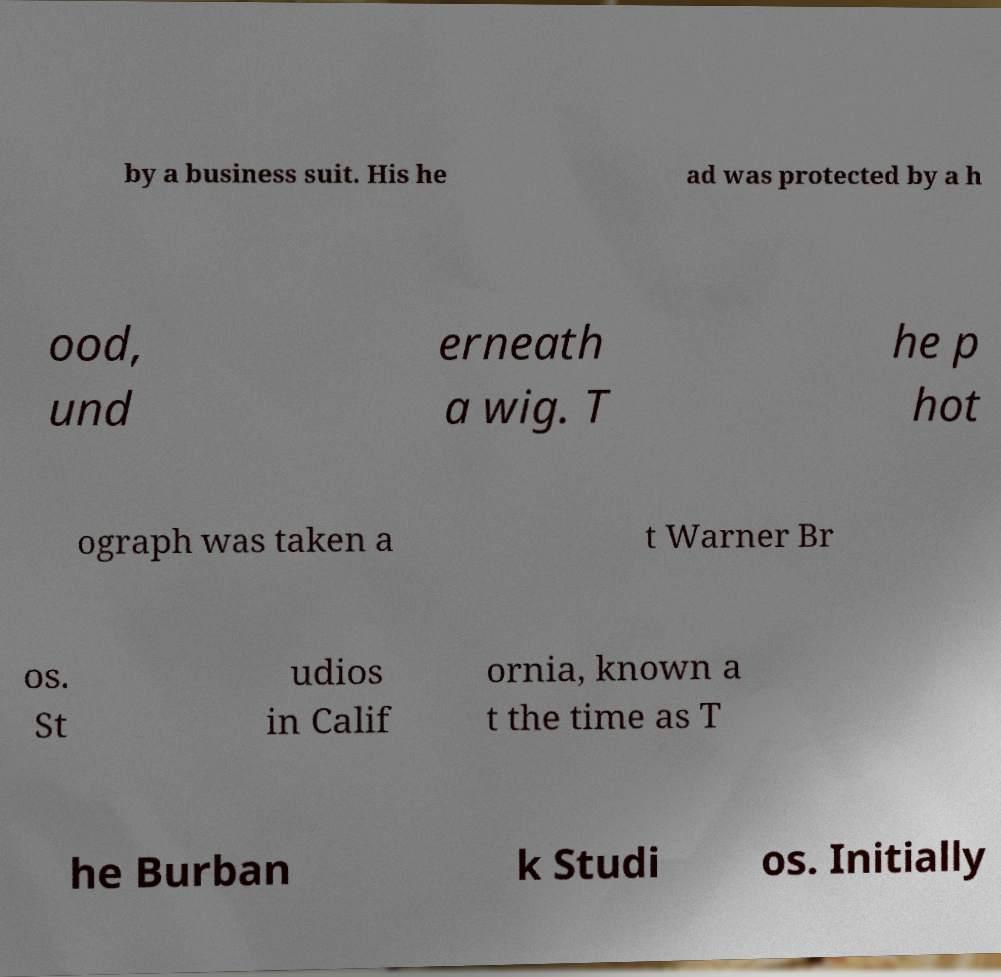Can you accurately transcribe the text from the provided image for me? by a business suit. His he ad was protected by a h ood, und erneath a wig. T he p hot ograph was taken a t Warner Br os. St udios in Calif ornia, known a t the time as T he Burban k Studi os. Initially 